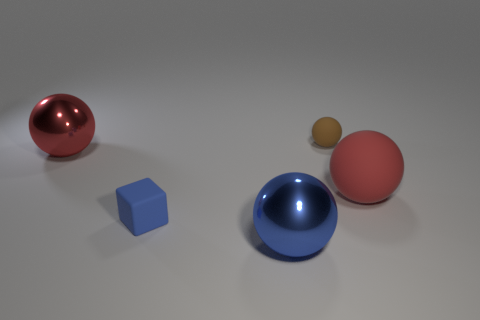Subtract all large blue shiny spheres. How many spheres are left? 3 Subtract 1 cubes. How many cubes are left? 0 Subtract all cyan blocks. How many red balls are left? 2 Subtract all brown spheres. How many spheres are left? 3 Add 2 red rubber things. How many objects exist? 7 Subtract all cubes. How many objects are left? 4 Subtract all cyan cubes. Subtract all cyan spheres. How many cubes are left? 1 Subtract all blue metallic balls. Subtract all blue matte blocks. How many objects are left? 3 Add 5 blue metal objects. How many blue metal objects are left? 6 Add 5 big red shiny spheres. How many big red shiny spheres exist? 6 